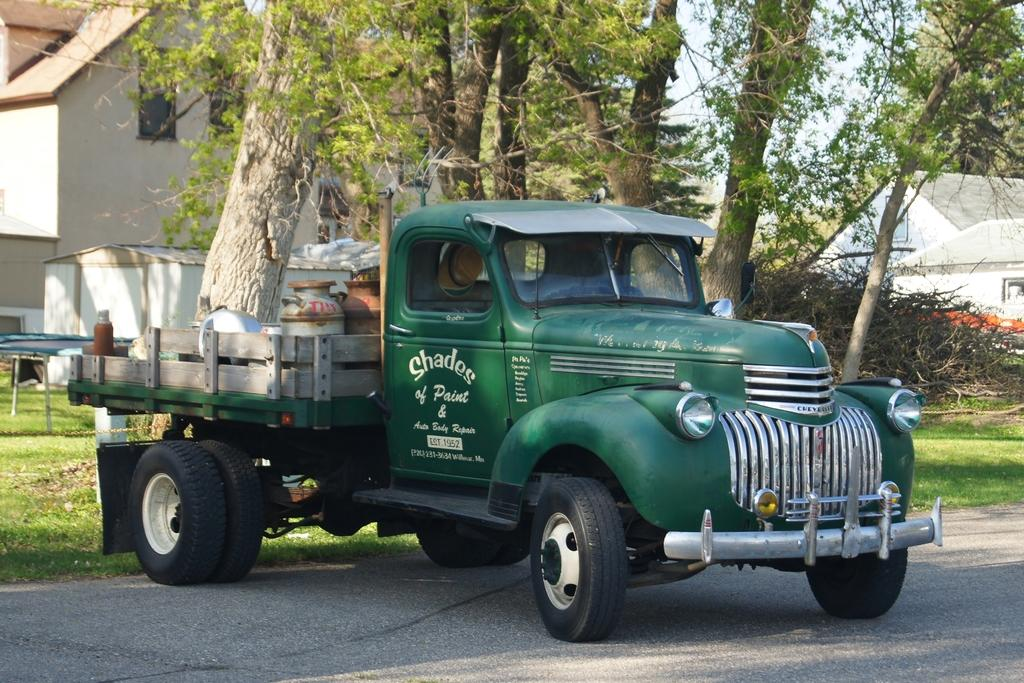What is inside the vehicle in the image? The facts do not specify the objects inside the vehicle, so we cannot answer this question definitively. What can be seen in the foreground of the image? There is a road visible in the image. What type of vegetation is present in the image? There is grass in the image, and trees are also visible. What structures can be seen in the background of the image? There are houses in the background of the image. What is visible in the sky in the image? The sky is visible in the background of the image. How many rabbits are hopping on the road in the image? There are no rabbits present in the image. What type of horse can be seen pulling the vehicle in the image? There is no horse present in the image, and the vehicle is not being pulled by any animal. 